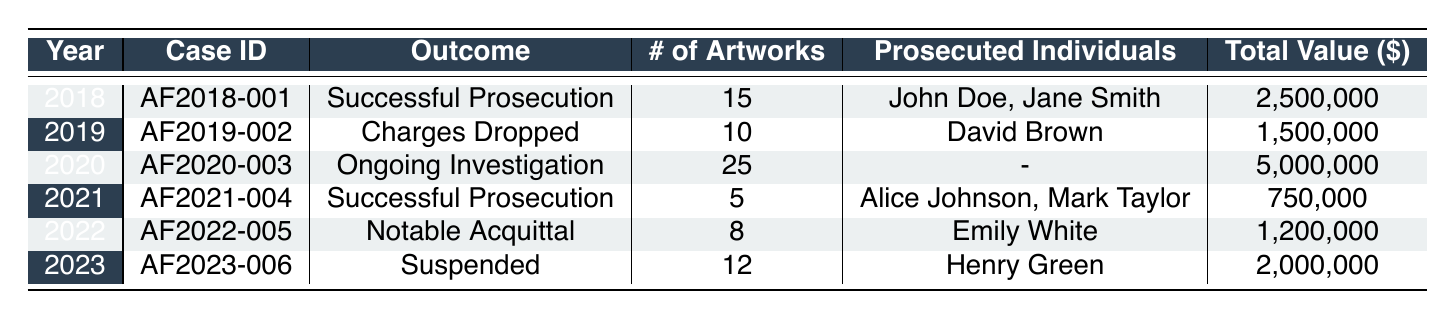What is the outcome of the art forgery case from 2021? The table shows that for the year 2021, the outcome listed is "Successful Prosecution."
Answer: Successful Prosecution How many artworks were involved in the 2020 case? From the table, it is indicated that the number of artworks in the 2020 case is 25.
Answer: 25 Which year had the highest total estimate value of artworks? By examining the total estimate values: 2,500,000 (2018), 1,500,000 (2019), 5,000,000 (2020), 750,000 (2021), 1,200,000 (2022), 2,000,000 (2023), it is clear that 5,000,000 in 2020 is the highest.
Answer: 2020 Did the number of artworks increase from 2019 to 2020? The number of artworks in 2019 is 10, while in 2020 it is 25. Since 25 is greater than 10, the number of artworks did increase.
Answer: Yes What is the total number of artworks across all cases listed in the table? Adding the number of artworks from each year gives: 15 (2018) + 10 (2019) + 25 (2020) + 5 (2021) + 8 (2022) + 12 (2023) = 75.
Answer: 75 Which individuals were prosecuted in the case from 2022? The 2022 case, as per the table, lists Emily White as the only prosecuted individual.
Answer: Emily White Is there any case with no prosecuted individuals listed? Looking at the table, the 2020 case shows that there are no prosecuted individuals listed, indicated by a hyphen.
Answer: Yes What was the outcome for the case with the lowest number of artworks? In the table, the case with the lowest number of artworks is from 2021, with 5 artworks, which has an outcome of "Successful Prosecution."
Answer: Successful Prosecution What was the average total value estimate of the artworks across all cases? The sum of total values is: 2,500,000 + 1,500,000 + 5,000,000 + 750,000 + 1,200,000 + 2,000,000 = 12,950,000. There are 6 cases, so the average is 12,950,000 / 6 = 2,158,333.33.
Answer: 2,158,333.33 In which year was a notable acquittal reported? The table specifies that the year with a "Notable Acquittal" outcome is 2022.
Answer: 2022 